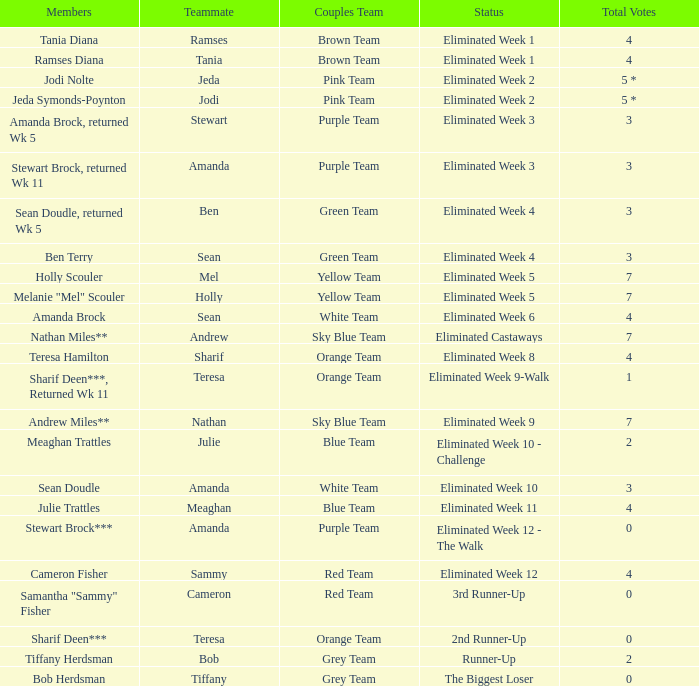What was the overall vote count for holly scouler? 7.0. 